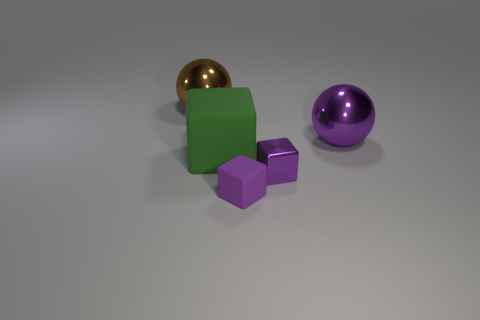Subtract all cyan balls. How many purple cubes are left? 2 Add 3 big brown balls. How many objects exist? 8 Subtract all purple blocks. How many blocks are left? 1 Subtract all cubes. How many objects are left? 2 Subtract all green blocks. Subtract all shiny cubes. How many objects are left? 3 Add 5 small purple things. How many small purple things are left? 7 Add 4 small purple cylinders. How many small purple cylinders exist? 4 Subtract 0 red spheres. How many objects are left? 5 Subtract all yellow cubes. Subtract all purple spheres. How many cubes are left? 3 